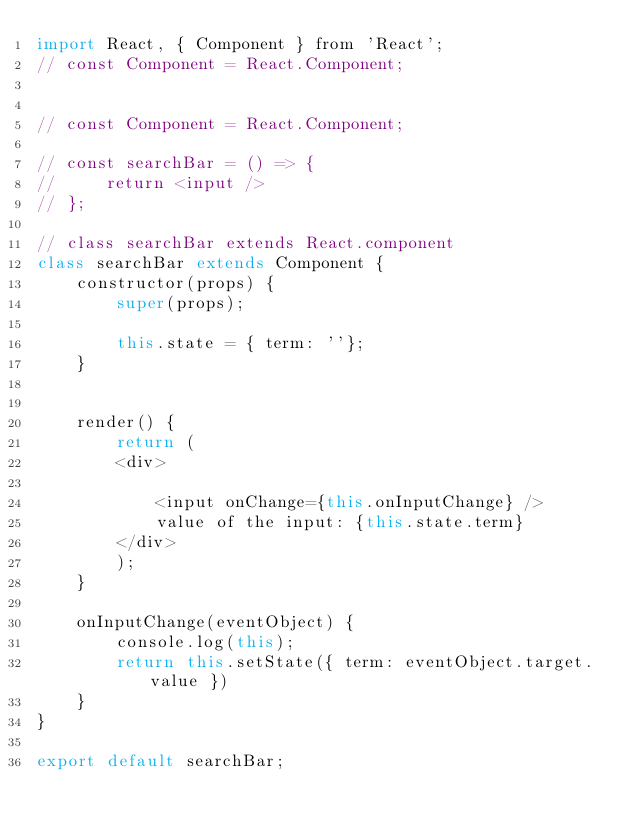<code> <loc_0><loc_0><loc_500><loc_500><_JavaScript_>import React, { Component } from 'React'; 
// const Component = React.Component;


// const Component = React.Component;

// const searchBar = () => {
//     return <input />
// };

// class searchBar extends React.component
class searchBar extends Component {
    constructor(props) {
        super(props);

        this.state = { term: ''};
    }


    render() {
        return (
        <div>    
            
            <input onChange={this.onInputChange} />
            value of the input: {this.state.term}
        </div>    
        );
    }

    onInputChange(eventObject) {
        console.log(this);
        return this.setState({ term: eventObject.target.value })
    }
}

export default searchBar;</code> 